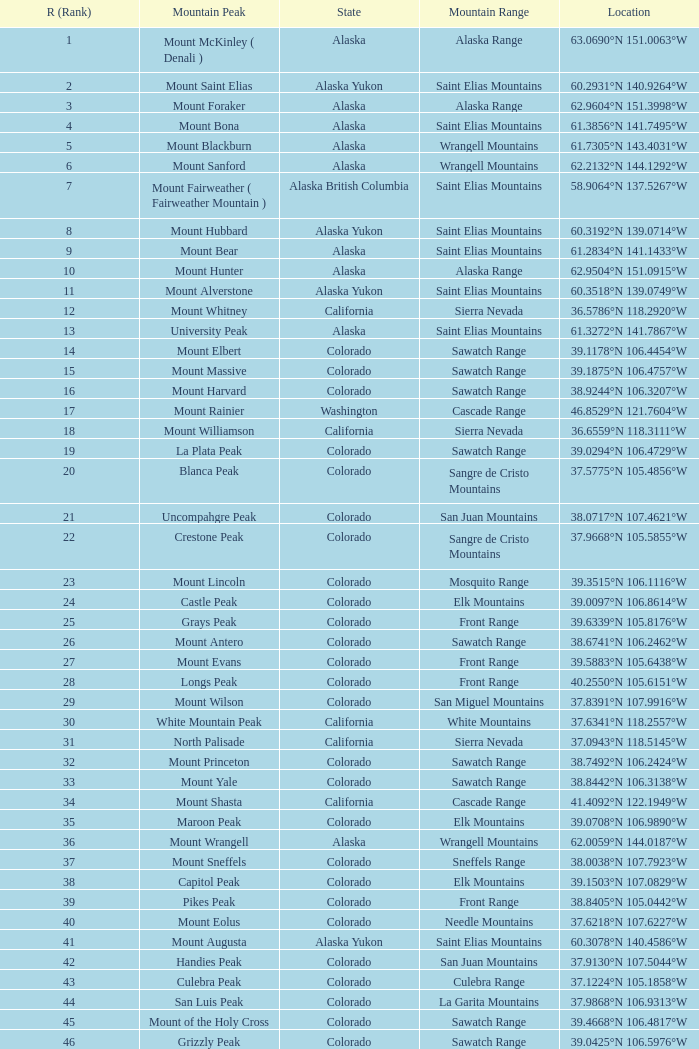What is the mountain peak when the location is 37.5775°n 105.4856°w? Blanca Peak. 